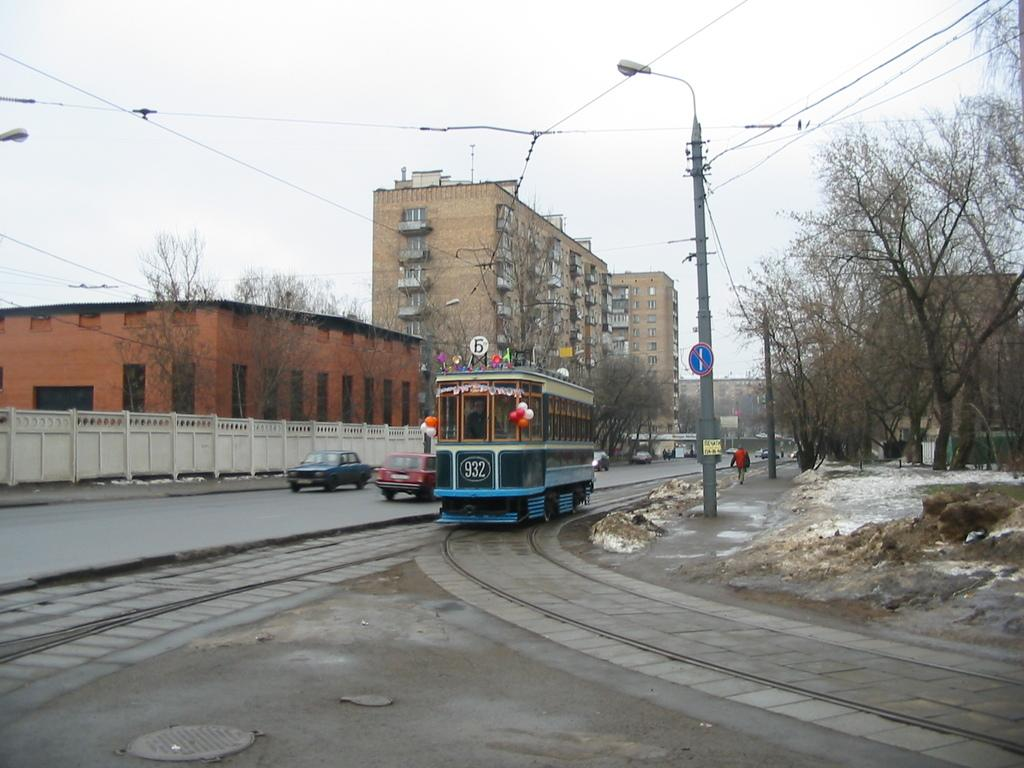<image>
Relay a brief, clear account of the picture shown. Streetcar number 932 is travelling on the tracks beside a roadway in the city. 